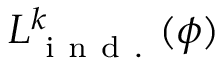Convert formula to latex. <formula><loc_0><loc_0><loc_500><loc_500>{ L } _ { i n d . } ^ { k } ( \phi )</formula> 